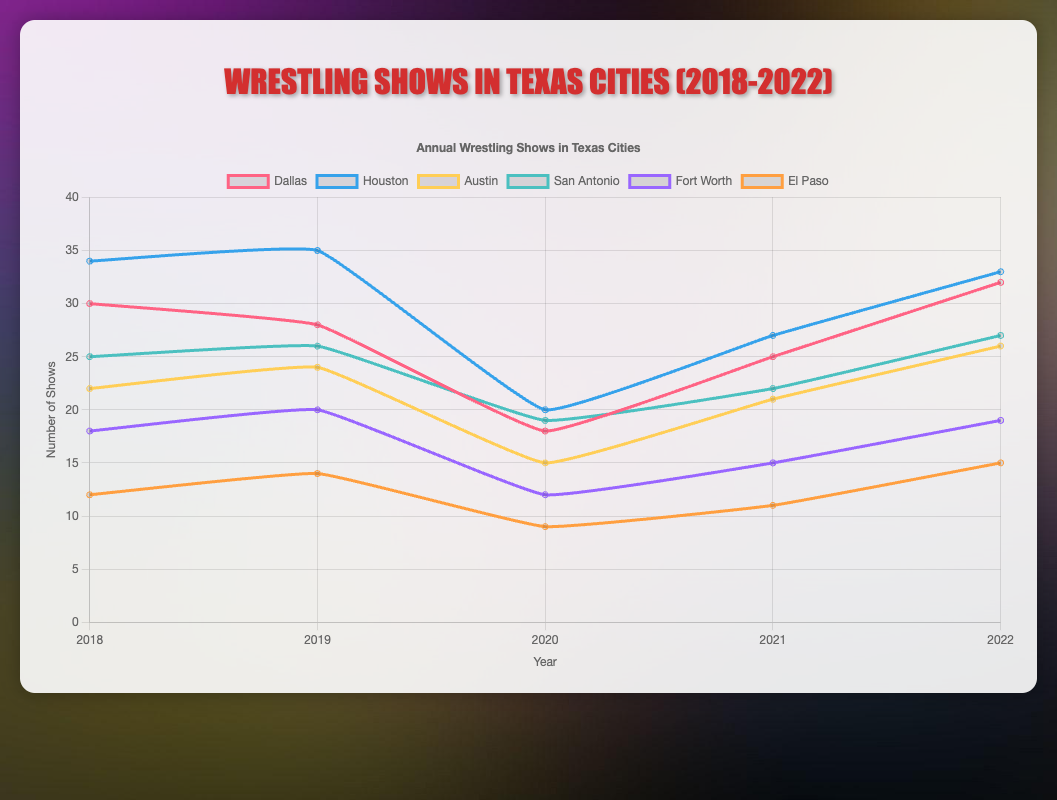What's the trend in the number of wrestling shows in Dallas from 2018 to 2022? The trend in Dallas shows a decrease from 30 in 2018 to 18 in 2020, followed by an increase to 32 in 2022.
Answer: Decreasing and then increasing In which year did Houston have the highest number of wrestling shows? The line for Houston peaks in 2019 with 35 shows.
Answer: 2019 Between 2020 and 2021, which city saw the greatest increase in the number of wrestling shows? Comparing the increases from 2020 to 2021, Dallas increased by 7 (25-18), Houston by 7 (27-20), Austin by 6 (21-15), San Antonio by 3 (22-19), Fort Worth by 3 (15-12), and El Paso by 2 (11-9). Therefore, Dallas and Houston both experienced the greatest increase of 7 shows each.
Answer: Dallas and Houston On average, how many wrestling shows were held in Austin from 2018 to 2022? The total number of Austin shows from 2018 to 2022 is 22 + 24 + 15 + 21 + 26 = 108. The average is 108 / 5 = 21.6.
Answer: 21.6 Which city had the least number of wrestling shows in 2020? In 2020, El Paso had the least number of shows with 9.
Answer: El Paso How did the number of wrestling shows in San Antonio change from 2018 to 2022? In 2018, San Antonio had 25 shows, and by 2022 the number increased to 27, with a small dip in 2020 to 19.
Answer: Slight increase with a dip in 2020 Which city had the highest increase in wrestling shows from 2021 to 2022? The increase is calculated for each city: Dallas (32-25=7), Houston (33-27=6), Austin (26-21=5), San Antonio (27-22=5), Fort Worth (19-15=4), El Paso (15-11=4). Dallas had the highest increase of 7 shows.
Answer: Dallas Compare the number of wrestling shows held in Fort Worth in 2018 and 2021. Which year had more? Fort Worth had 18 shows in 2018 and 15 shows in 2021. Therefore, 2018 had more.
Answer: 2018 If you sum up the total wrestling shows held in Houston, Austin, and El Paso in 2019, what is the total? The respective sums for Houston (35), Austin (24), and El Paso (14) are 35 + 24 + 14 = 73.
Answer: 73 